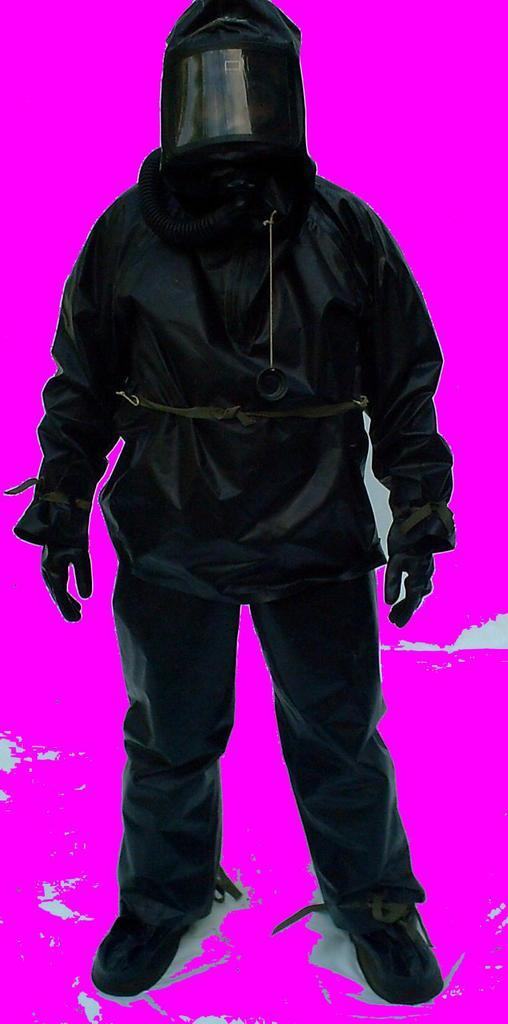Who or what is present in the image? There is a person in the image. What is the person doing in the image? The person is standing. What is the person wearing on their head in the image? The person is wearing a helmet. What type of tomatoes can be seen growing in the image? There are no tomatoes present in the image; it features a person standing and wearing a helmet. What kind of yam dish is being prepared by the minister in the image? There is no minister or yam dish present in the image. 